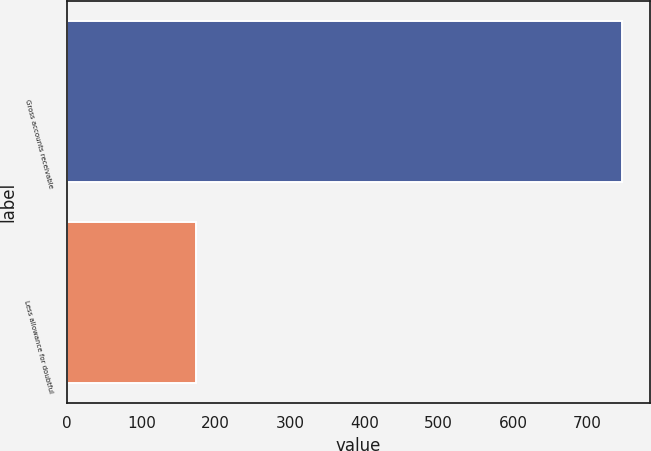Convert chart to OTSL. <chart><loc_0><loc_0><loc_500><loc_500><bar_chart><fcel>Gross accounts receivable<fcel>Less allowance for doubtful<nl><fcel>747.3<fcel>173.1<nl></chart> 